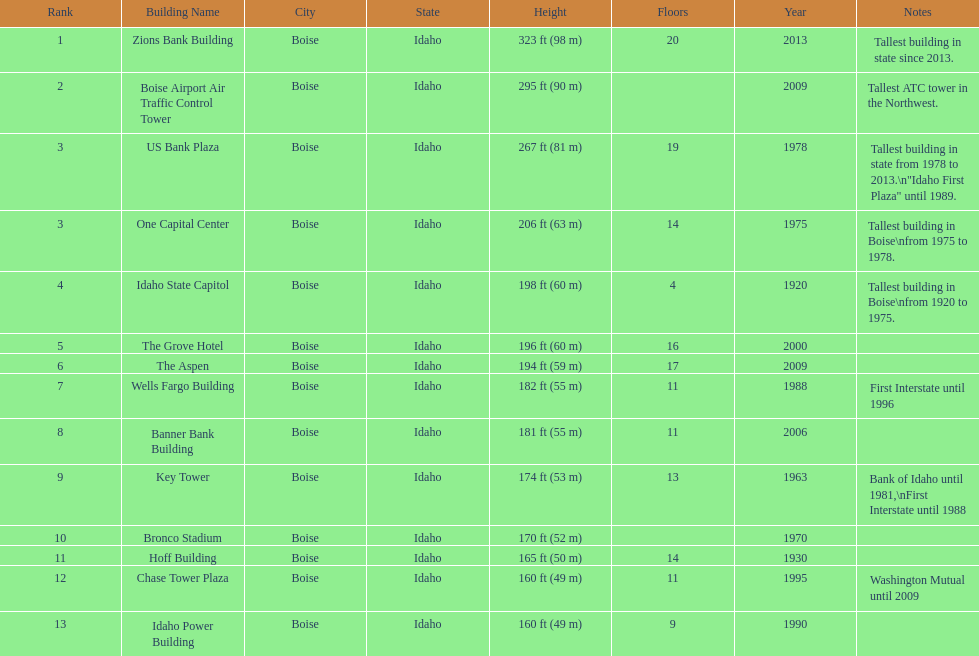What are the number of floors the us bank plaza has? 19. 